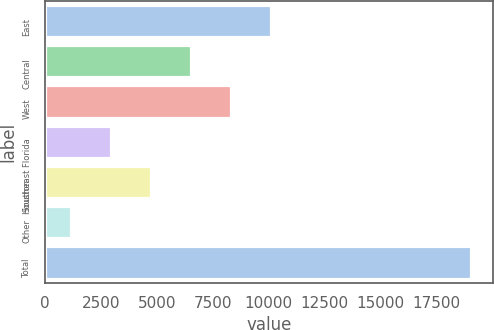<chart> <loc_0><loc_0><loc_500><loc_500><bar_chart><fcel>East<fcel>Central<fcel>West<fcel>Southeast Florida<fcel>Houston<fcel>Other<fcel>Total<nl><fcel>10109.5<fcel>6536.1<fcel>8322.8<fcel>2962.7<fcel>4749.4<fcel>1176<fcel>19043<nl></chart> 